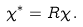<formula> <loc_0><loc_0><loc_500><loc_500>\chi ^ { * } = R \chi \, .</formula> 